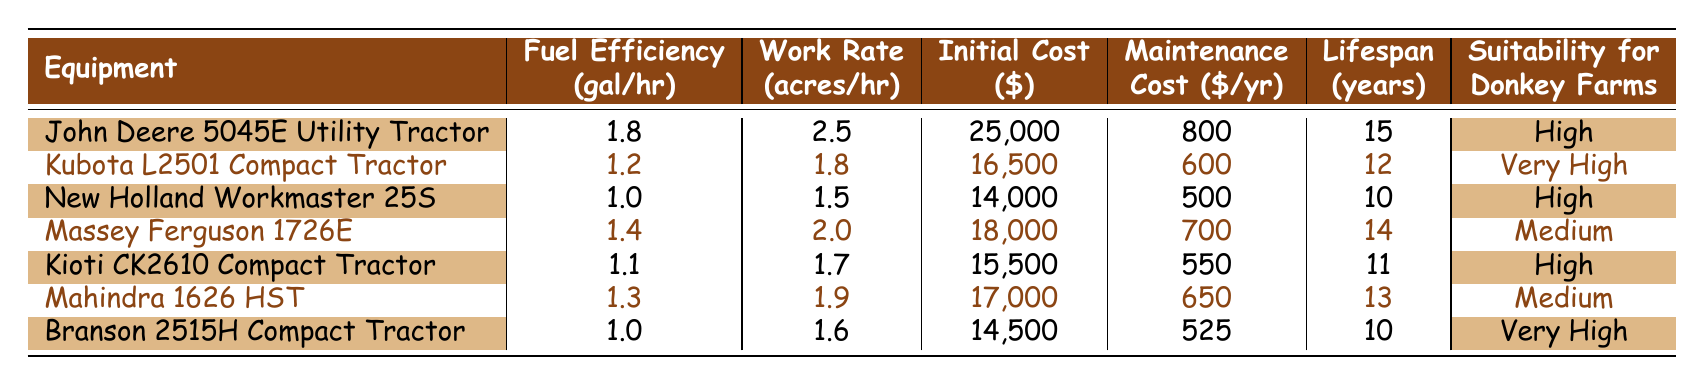What is the fuel efficiency of the Kubota L2501 Compact Tractor? The table shows that the fuel efficiency for the Kubota L2501 Compact Tractor is listed as 1.2 gal/hr.
Answer: 1.2 gal/hr Which equipment has the highest initial cost? By inspecting the "Initial Cost ($)" column, the John Deere 5045E Utility Tractor has the highest cost at $25,000.
Answer: $25,000 What is the maintenance cost for Mahindra 1626 HST? The table indicates that the maintenance cost for Mahindra 1626 HST is $650 per year according to the "Maintenance Cost ($/yr)" column.
Answer: $650 Which two tractors are considered "Very High" in suitability for donkey farms? According to the "Suitability for Donkey Farms" column, the Kubota L2501 Compact Tractor and Branson 2515H Compact Tractor both have a rating of "Very High."
Answer: Kubota L2501 Compact Tractor and Branson 2515H Compact Tractor What is the average lifespan of the tractors listed in the table? Adding the lifespans from the "Lifespan (years)" column (15 + 12 + 10 + 14 + 11 + 13 + 10) results in a total of 95 years. Dividing by the 7 tractors gives an average lifespan of 95/7, which is approximately 13.57 years.
Answer: 13.57 years Does the New Holland Workmaster 25S have a lower work rate than the Massey Ferguson 1726E? By comparing the "Work Rate (acres/hr)" columns, New Holland Workmaster 25S has a work rate of 1.5 acres/hr, while Massey Ferguson 1726E has a work rate of 2.0 acres/hr. Therefore, the statement is true.
Answer: Yes What is the difference in fuel efficiency between the John Deere 5045E and the Kioti CK2610? The fuel efficiency for John Deere 5045E is 1.8 gal/hr and for Kioti CK2610 it is 1.1 gal/hr. The difference is calculated as 1.8 - 1.1 = 0.7 gal/hr.
Answer: 0.7 gal/hr Which tractor offers the best combination of low initial cost and high work rate? Looking at the "Initial Cost ($)" and "Work Rate (acres/hr)" together, the Kubota L2501 has a cost of $16,500 and work rate of 1.8 acres/hr, which provides a good balance compared to others. Although there are other tractors with lower initial costs or higher work rates when analyzing both factors, none provides a better combination in the average range than this one.
Answer: Kubota L2501 Compact Tractor 